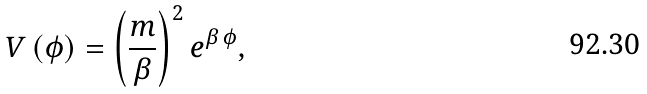Convert formula to latex. <formula><loc_0><loc_0><loc_500><loc_500>V \left ( \phi \right ) = \left ( \frac { m } { \beta } \right ) ^ { 2 } e ^ { \beta \, \phi } ,</formula> 